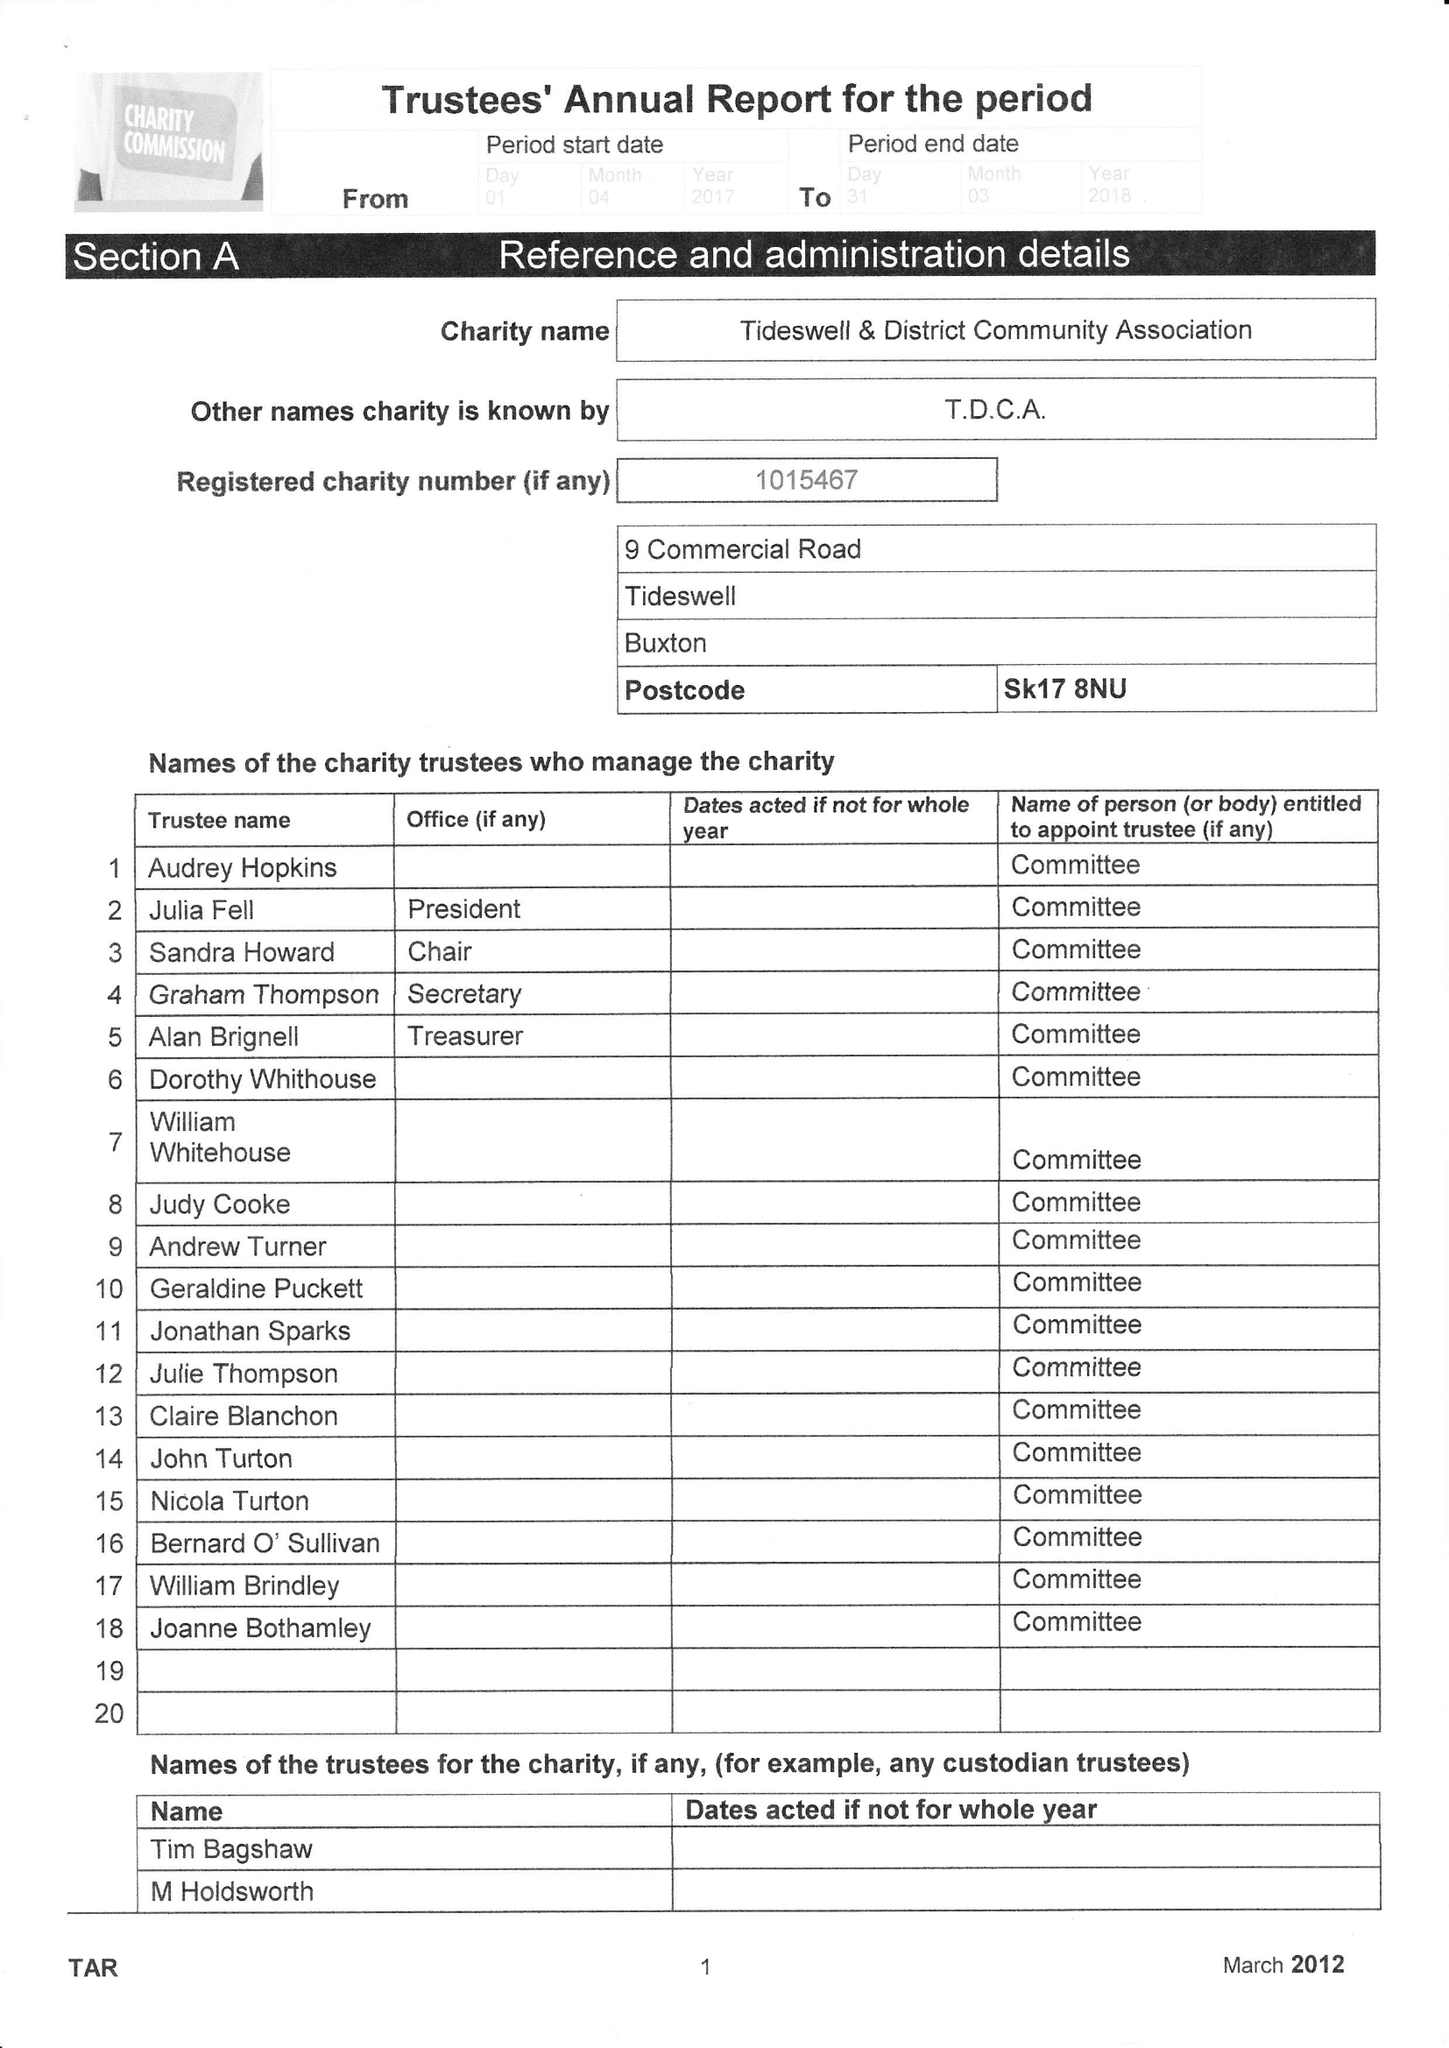What is the value for the charity_name?
Answer the question using a single word or phrase. Tideswell and District Community Association 